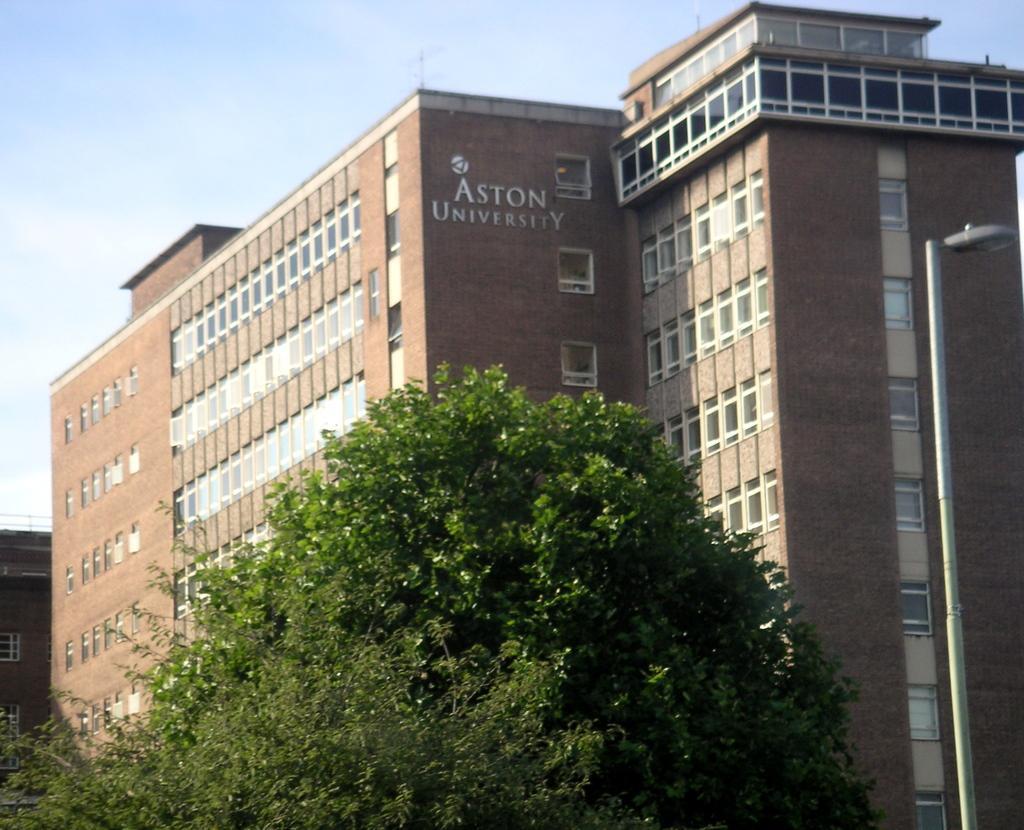How would you summarize this image in a sentence or two? In this image, we can see buildings and there is some text on the wall and we can see trees and a light pole. At the top, there is sky. 